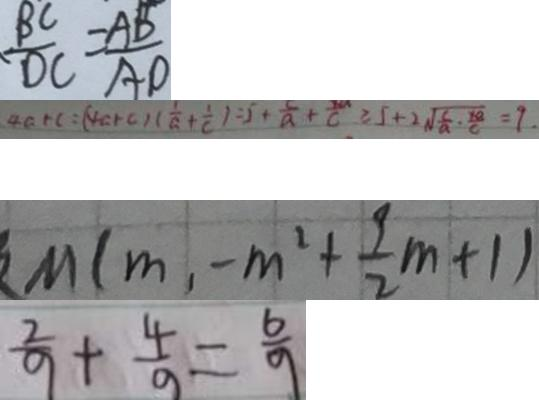Convert formula to latex. <formula><loc_0><loc_0><loc_500><loc_500>\frac { B C } { D C } = \frac { A B } { A D } 
 4 a + c = ( 4 a + c ) ( \frac { 1 } { a } + \frac { 1 } { c } ) = 5 + \frac { 5 } { a } + \frac { 1 0 } { c } \geq 5 + 2 \sqrt { \frac { c } { a } \cdot \frac { 1 8 } { c } } = 9 . 
 M ( m , - m ^ { 2 } + \frac { 9 } { 2 } m + 1 ) 
 \frac { 2 } { 9 } + \frac { 4 } { 9 } = \frac { 6 } { 9 }</formula> 